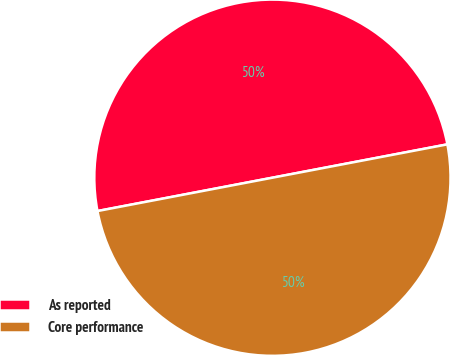<chart> <loc_0><loc_0><loc_500><loc_500><pie_chart><fcel>As reported<fcel>Core performance<nl><fcel>50.0%<fcel>50.0%<nl></chart> 